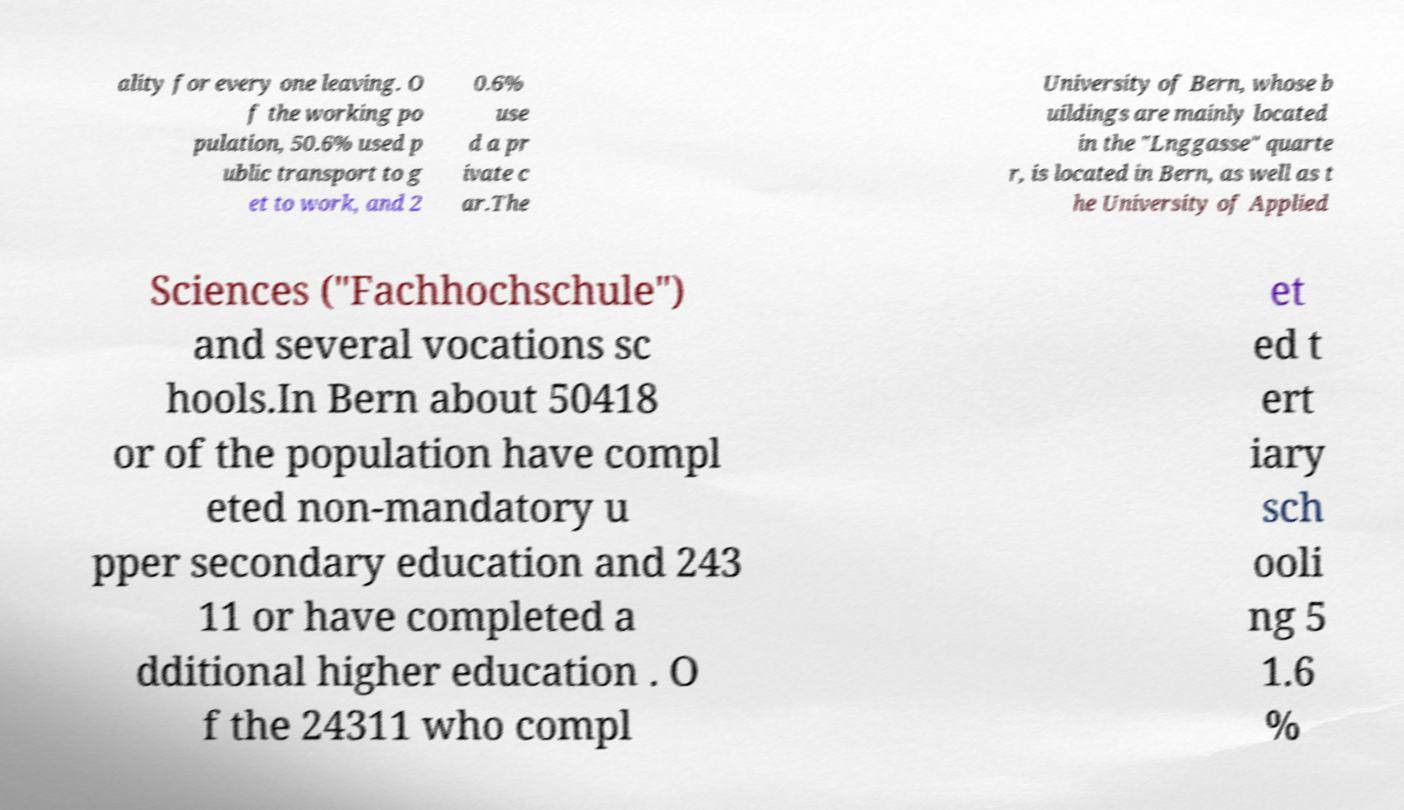There's text embedded in this image that I need extracted. Can you transcribe it verbatim? ality for every one leaving. O f the working po pulation, 50.6% used p ublic transport to g et to work, and 2 0.6% use d a pr ivate c ar.The University of Bern, whose b uildings are mainly located in the "Lnggasse" quarte r, is located in Bern, as well as t he University of Applied Sciences ("Fachhochschule") and several vocations sc hools.In Bern about 50418 or of the population have compl eted non-mandatory u pper secondary education and 243 11 or have completed a dditional higher education . O f the 24311 who compl et ed t ert iary sch ooli ng 5 1.6 % 